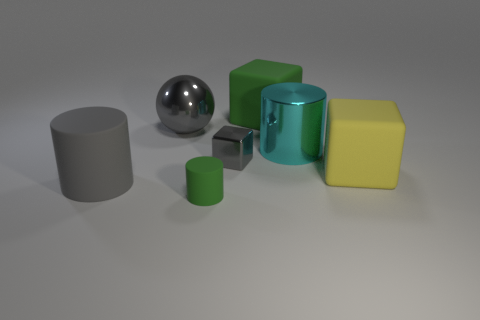Is there anything else that is the same shape as the large gray metal thing?
Offer a terse response. No. What number of large purple blocks are there?
Offer a terse response. 0. What shape is the big gray object that is the same material as the tiny cylinder?
Provide a succinct answer. Cylinder. Do the cylinder that is to the left of the green matte cylinder and the block that is on the right side of the large green matte object have the same color?
Your response must be concise. No. Is the number of large gray spheres that are right of the shiny sphere the same as the number of large metal spheres?
Keep it short and to the point. No. How many gray matte cylinders are to the right of the big gray cylinder?
Your answer should be compact. 0. How big is the sphere?
Your answer should be very brief. Large. What is the color of the other cube that is the same material as the large yellow cube?
Keep it short and to the point. Green. How many green cylinders are the same size as the gray cylinder?
Provide a succinct answer. 0. Is the material of the big cylinder behind the big gray matte thing the same as the gray block?
Provide a short and direct response. Yes. 